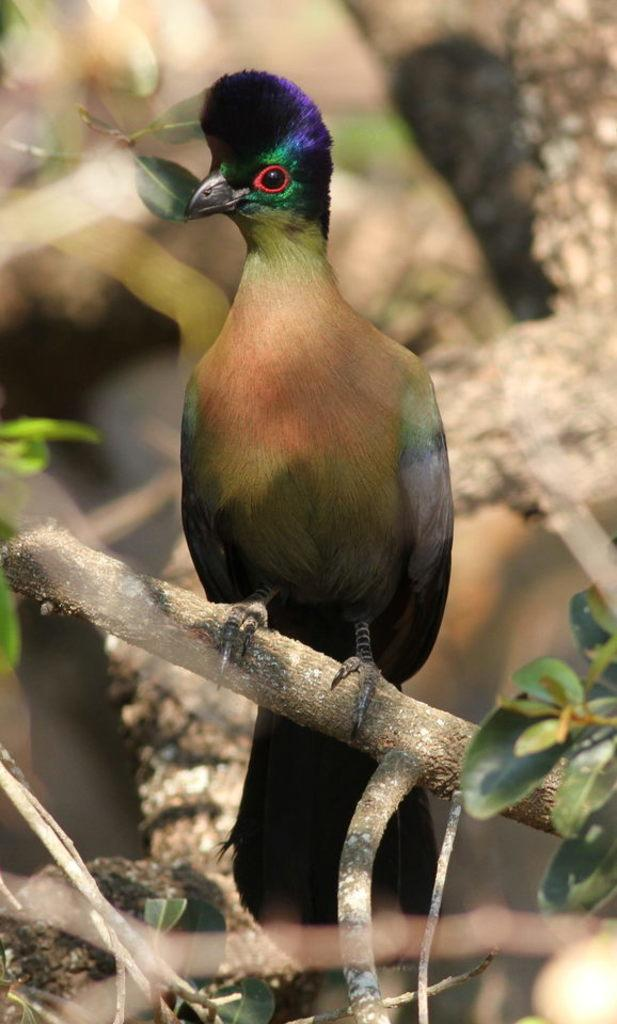What type of animal can be seen in the image? There is a bird in the image. Where is the bird located in the image? The bird is on a branch of a tree. What type of boat can be seen in the image? There is no boat present in the image; it features a bird on a tree branch. How many eggs are visible in the image? There are no eggs present in the image; it features a bird on a tree branch. 